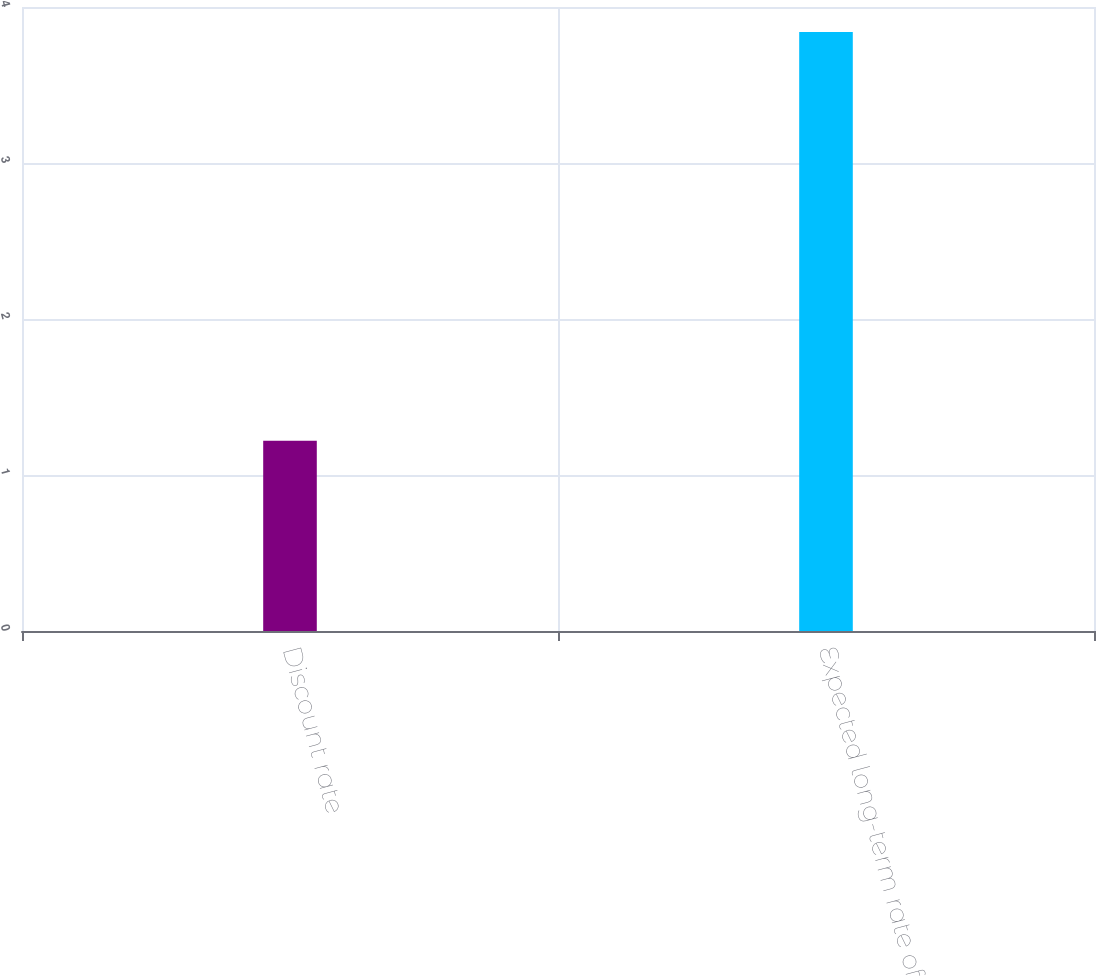Convert chart. <chart><loc_0><loc_0><loc_500><loc_500><bar_chart><fcel>Discount rate<fcel>Expected long-term rate of<nl><fcel>1.22<fcel>3.84<nl></chart> 